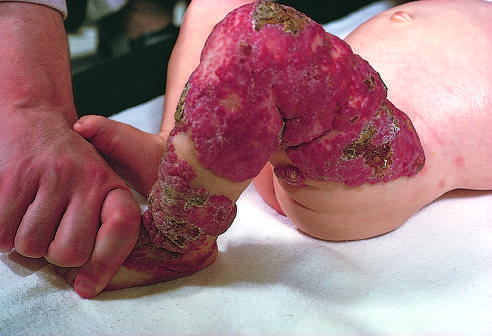had the congenital capillary hemangioma at birth after the lesion undergone spontaneous regression?
Answer the question using a single word or phrase. Yes 